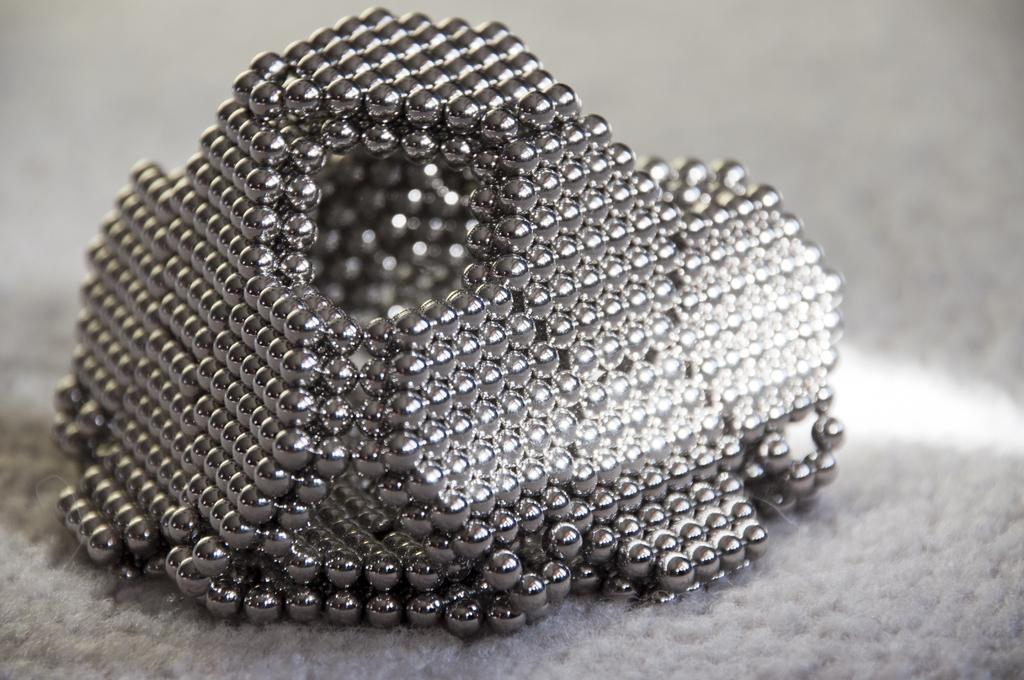What is the main subject of the image? We cannot confirm the main subject of the image based on the provided transcript. What grade did the team's grandmother receive on her last report card? There is no mention of a team, a grandmother, or a report card in the provided transcript, so it is not possible to answer that question. 